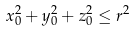<formula> <loc_0><loc_0><loc_500><loc_500>x _ { 0 } ^ { 2 } + y _ { 0 } ^ { 2 } + z _ { 0 } ^ { 2 } \leq r ^ { 2 }</formula> 